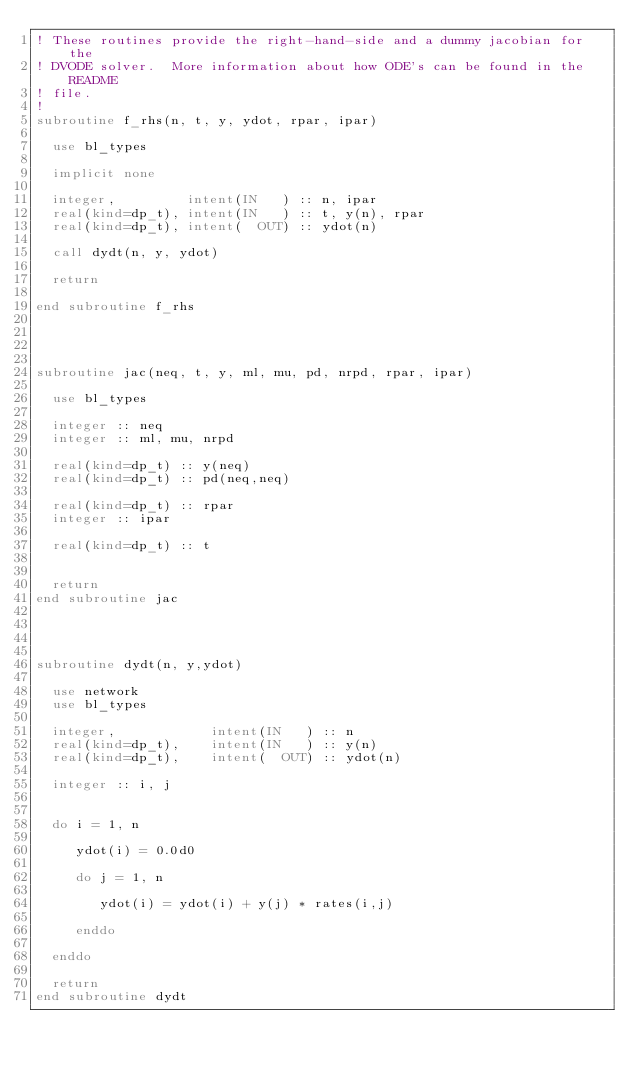Convert code to text. <code><loc_0><loc_0><loc_500><loc_500><_FORTRAN_>! These routines provide the right-hand-side and a dummy jacobian for the 
! DVODE solver.  More information about how ODE's can be found in the README 
! file.
!
subroutine f_rhs(n, t, y, ydot, rpar, ipar)

  use bl_types

  implicit none

  integer,         intent(IN   ) :: n, ipar
  real(kind=dp_t), intent(IN   ) :: t, y(n), rpar
  real(kind=dp_t), intent(  OUT) :: ydot(n)

  call dydt(n, y, ydot)

  return

end subroutine f_rhs
  



subroutine jac(neq, t, y, ml, mu, pd, nrpd, rpar, ipar)

  use bl_types

  integer :: neq
  integer :: ml, mu, nrpd

  real(kind=dp_t) :: y(neq)
  real(kind=dp_t) :: pd(neq,neq)

  real(kind=dp_t) :: rpar
  integer :: ipar

  real(kind=dp_t) :: t


  return
end subroutine jac




subroutine dydt(n, y,ydot)

  use network
  use bl_types

  integer,            intent(IN   ) :: n
  real(kind=dp_t),    intent(IN   ) :: y(n)
  real(kind=dp_t),    intent(  OUT) :: ydot(n)

  integer :: i, j


  do i = 1, n

     ydot(i) = 0.0d0

     do j = 1, n

        ydot(i) = ydot(i) + y(j) * rates(i,j)

     enddo

  enddo

  return
end subroutine dydt
</code> 